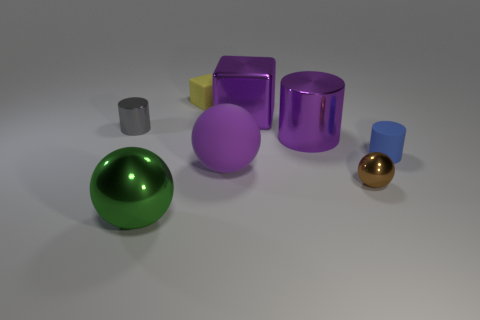Does the large sphere to the right of the tiny rubber block have the same material as the green sphere?
Your response must be concise. No. There is a metallic sphere that is behind the metallic thing in front of the tiny brown shiny sphere; what number of objects are to the right of it?
Make the answer very short. 1. Does the purple thing in front of the blue thing have the same shape as the gray object?
Your answer should be very brief. No. What number of things are small gray metal objects or tiny rubber objects that are in front of the tiny yellow matte thing?
Your response must be concise. 2. Is the number of large objects that are on the right side of the large green sphere greater than the number of big brown matte cubes?
Provide a succinct answer. Yes. Are there an equal number of matte blocks that are on the right side of the small yellow rubber object and purple rubber spheres that are behind the big green metal sphere?
Offer a terse response. No. There is a cylinder left of the big metal cube; is there a big object that is behind it?
Offer a very short reply. Yes. What shape is the small yellow thing?
Provide a succinct answer. Cube. What size is the matte thing that is behind the small cylinder to the right of the small yellow matte object?
Your answer should be very brief. Small. What size is the matte object that is behind the gray object?
Offer a very short reply. Small. 